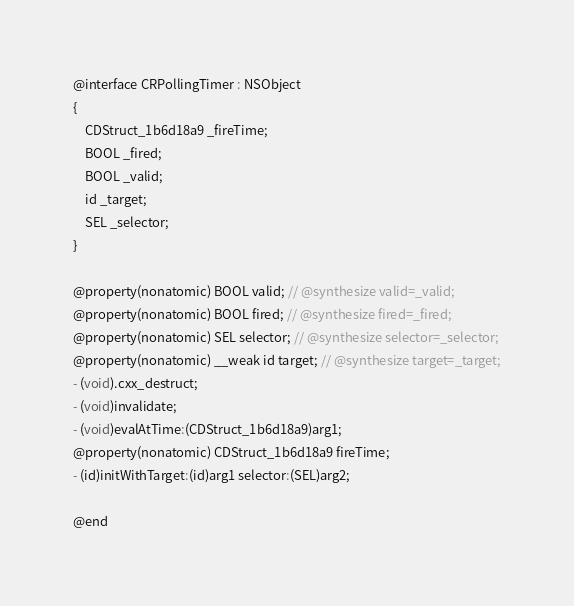<code> <loc_0><loc_0><loc_500><loc_500><_C_>
@interface CRPollingTimer : NSObject
{
    CDStruct_1b6d18a9 _fireTime;
    BOOL _fired;
    BOOL _valid;
    id _target;
    SEL _selector;
}

@property(nonatomic) BOOL valid; // @synthesize valid=_valid;
@property(nonatomic) BOOL fired; // @synthesize fired=_fired;
@property(nonatomic) SEL selector; // @synthesize selector=_selector;
@property(nonatomic) __weak id target; // @synthesize target=_target;
- (void).cxx_destruct;
- (void)invalidate;
- (void)evalAtTime:(CDStruct_1b6d18a9)arg1;
@property(nonatomic) CDStruct_1b6d18a9 fireTime;
- (id)initWithTarget:(id)arg1 selector:(SEL)arg2;

@end

</code> 